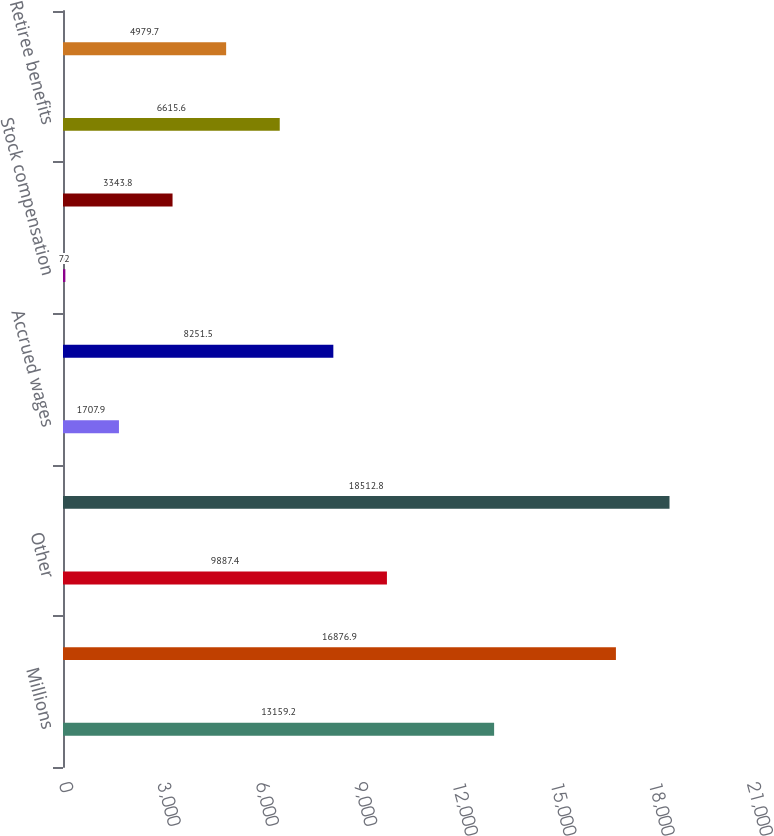Convert chart. <chart><loc_0><loc_0><loc_500><loc_500><bar_chart><fcel>Millions<fcel>Property<fcel>Other<fcel>Total deferred income tax<fcel>Accrued wages<fcel>Accrued casualty costs<fcel>Stock compensation<fcel>Debt and leases<fcel>Retiree benefits<fcel>Credits<nl><fcel>13159.2<fcel>16876.9<fcel>9887.4<fcel>18512.8<fcel>1707.9<fcel>8251.5<fcel>72<fcel>3343.8<fcel>6615.6<fcel>4979.7<nl></chart> 